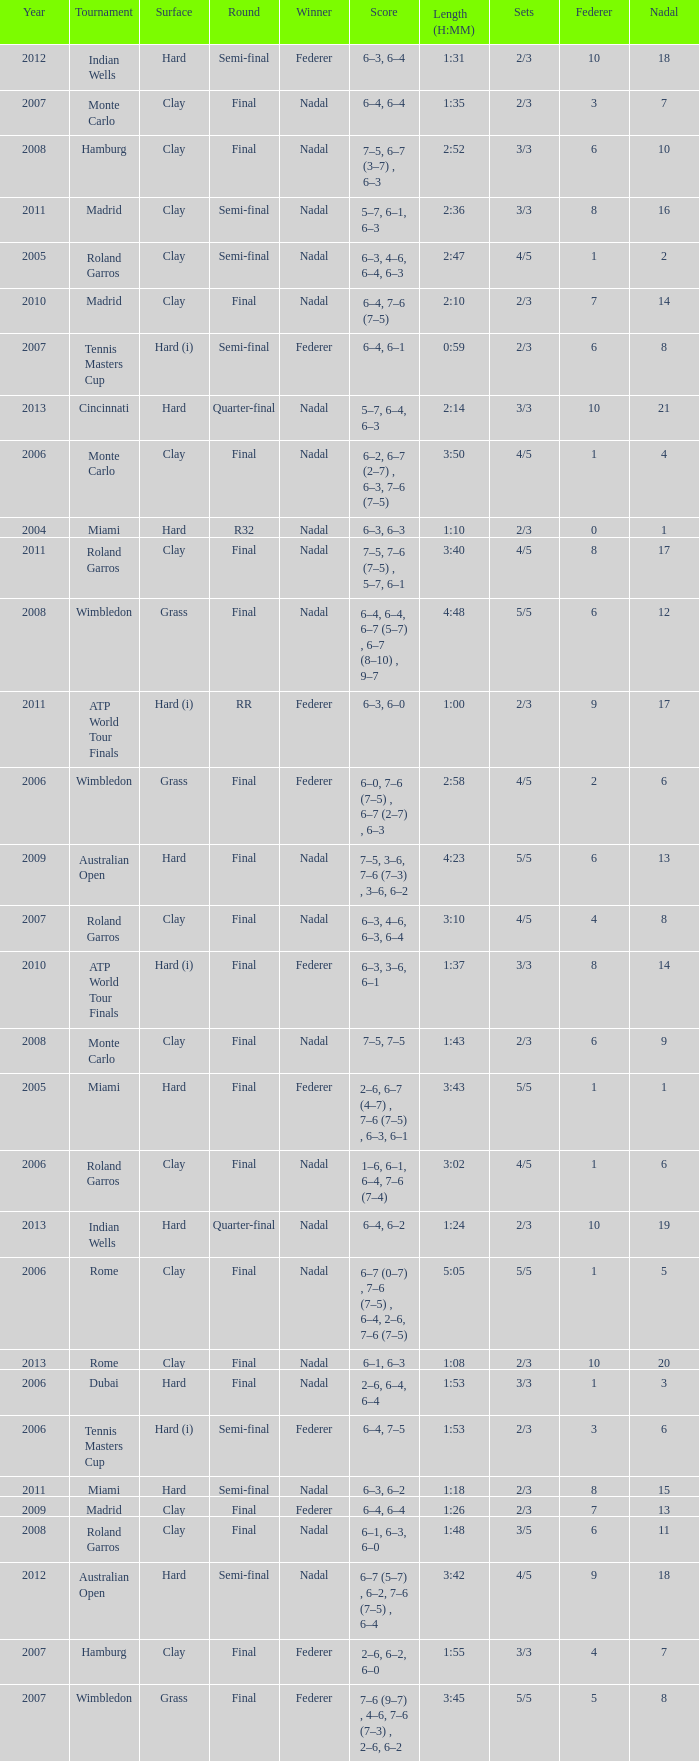What were the sets when Federer had 6 and a nadal of 13? 5/5. 